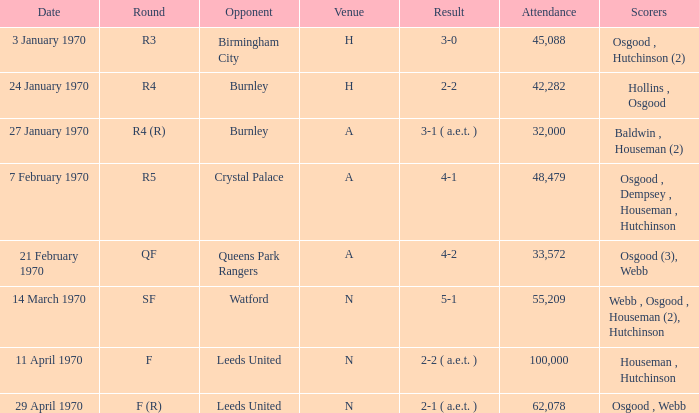What round was the game with a result of 5-1 at N venue? SF. 